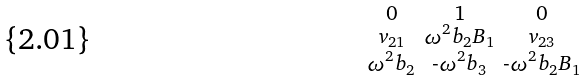Convert formula to latex. <formula><loc_0><loc_0><loc_500><loc_500>\begin{smallmatrix} 0 & 1 & 0 \\ v _ { 2 1 } & \omega ^ { 2 } b _ { 2 } B _ { 1 } & v _ { 2 3 } \\ \omega ^ { 2 } b _ { 2 } & \text {-} \omega ^ { 2 } b _ { 3 } & \text {-} \omega ^ { 2 } b _ { 2 } B _ { 1 } \end{smallmatrix}</formula> 